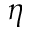<formula> <loc_0><loc_0><loc_500><loc_500>\eta</formula> 